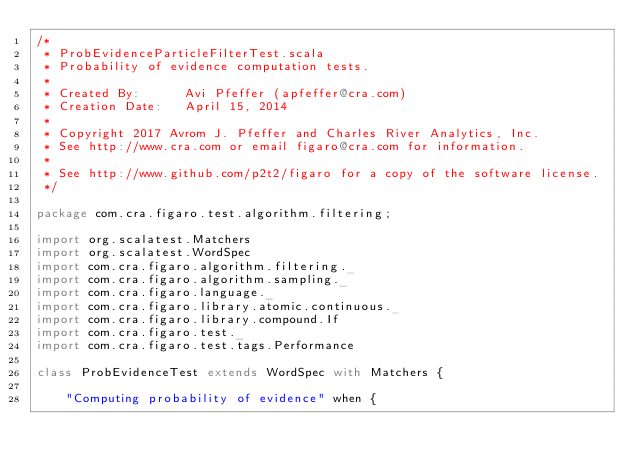Convert code to text. <code><loc_0><loc_0><loc_500><loc_500><_Scala_>/*
 * ProbEvidenceParticleFilterTest.scala
 * Probability of evidence computation tests.
 * 
 * Created By:      Avi Pfeffer (apfeffer@cra.com)
 * Creation Date:   April 15, 2014
 * 
 * Copyright 2017 Avrom J. Pfeffer and Charles River Analytics, Inc.
 * See http://www.cra.com or email figaro@cra.com for information.
 * 
 * See http://www.github.com/p2t2/figaro for a copy of the software license.
 */

package com.cra.figaro.test.algorithm.filtering;

import org.scalatest.Matchers
import org.scalatest.WordSpec
import com.cra.figaro.algorithm.filtering._
import com.cra.figaro.algorithm.sampling._
import com.cra.figaro.language._
import com.cra.figaro.library.atomic.continuous._
import com.cra.figaro.library.compound.If
import com.cra.figaro.test._
import com.cra.figaro.test.tags.Performance

class ProbEvidenceTest extends WordSpec with Matchers {
  
    "Computing probability of evidence" when {</code> 